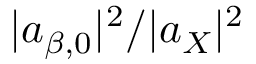<formula> <loc_0><loc_0><loc_500><loc_500>| a _ { \beta , 0 } | ^ { 2 } / | a _ { X } | ^ { 2 }</formula> 